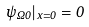<formula> <loc_0><loc_0><loc_500><loc_500>\psi _ { \Omega 0 } | _ { x = 0 } = 0</formula> 